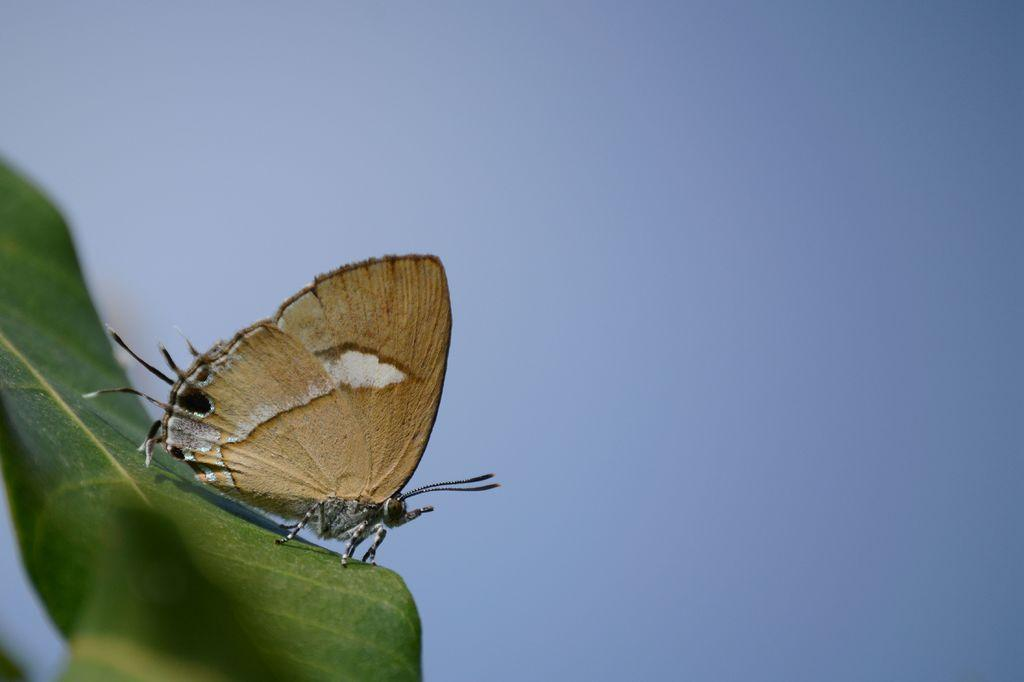What is the main subject of the image? The main subject of the image is a green leaf. Is there anything on the leaf? Yes, there is an insect of brown color on the leaf. What color can be seen in the background of the image? The background of the image includes a blue color. What type of pot is visible in the image? There is no pot present in the image. Is there a gun visible in the image? There is no gun present in the image. 